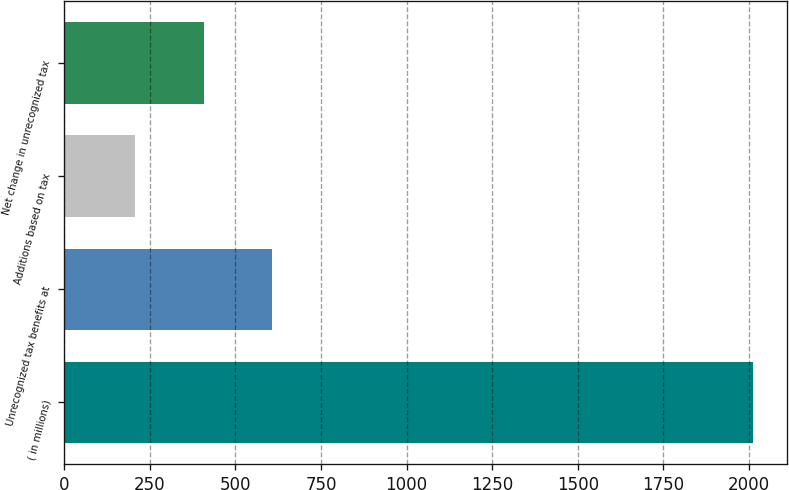Convert chart. <chart><loc_0><loc_0><loc_500><loc_500><bar_chart><fcel>( in millions)<fcel>Unrecognized tax benefits at<fcel>Additions based on tax<fcel>Net change in unrecognized tax<nl><fcel>2012<fcel>607.8<fcel>206.6<fcel>407.2<nl></chart> 